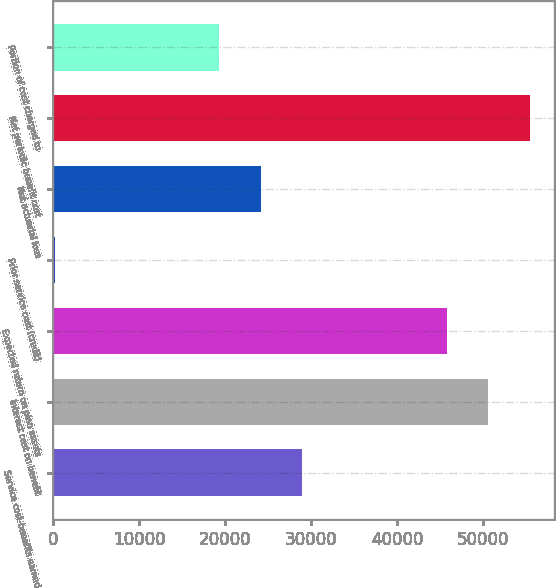Convert chart to OTSL. <chart><loc_0><loc_0><loc_500><loc_500><bar_chart><fcel>Service cost-benefits earned<fcel>Interest cost on benefit<fcel>Expected return on plan assets<fcel>Prior service cost (credit)<fcel>Net actuarial loss<fcel>Net periodic benefit cost<fcel>Portion of cost charged to<nl><fcel>28953.8<fcel>50609.4<fcel>45793<fcel>179<fcel>24137.4<fcel>55425.8<fcel>19321<nl></chart> 